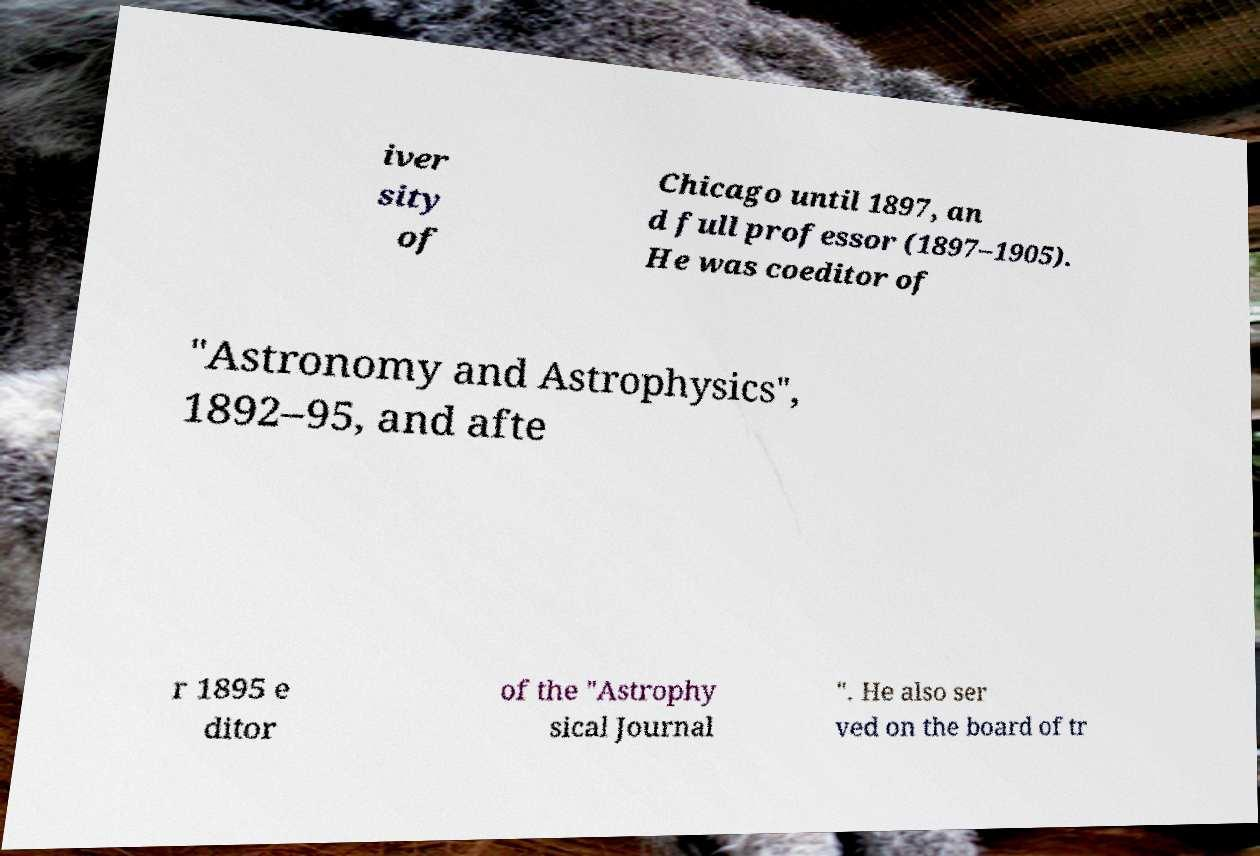Could you assist in decoding the text presented in this image and type it out clearly? iver sity of Chicago until 1897, an d full professor (1897–1905). He was coeditor of "Astronomy and Astrophysics", 1892–95, and afte r 1895 e ditor of the "Astrophy sical Journal ". He also ser ved on the board of tr 